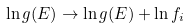Convert formula to latex. <formula><loc_0><loc_0><loc_500><loc_500>\ln g ( E ) \to \ln g ( E ) + \ln f _ { i }</formula> 